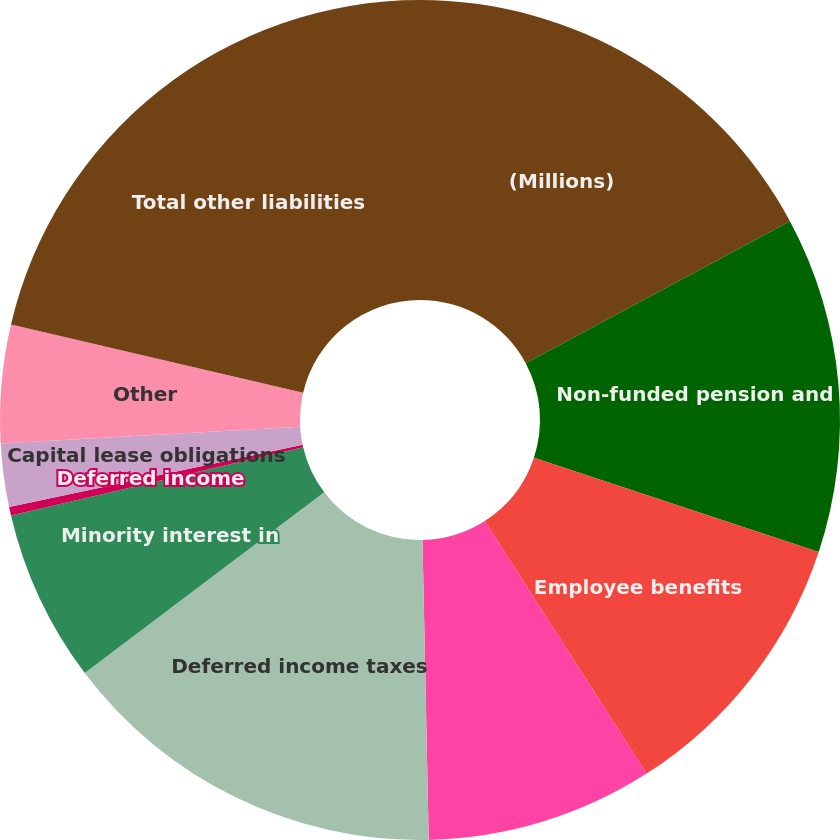<chart> <loc_0><loc_0><loc_500><loc_500><pie_chart><fcel>(Millions)<fcel>Non-funded pension and<fcel>Employee benefits<fcel>Product and other claims<fcel>Deferred income taxes<fcel>Minority interest in<fcel>Deferred income<fcel>Capital lease obligations<fcel>Other<fcel>Total other liabilities<nl><fcel>17.15%<fcel>12.94%<fcel>10.84%<fcel>8.74%<fcel>15.04%<fcel>6.64%<fcel>0.33%<fcel>2.43%<fcel>4.54%<fcel>21.35%<nl></chart> 